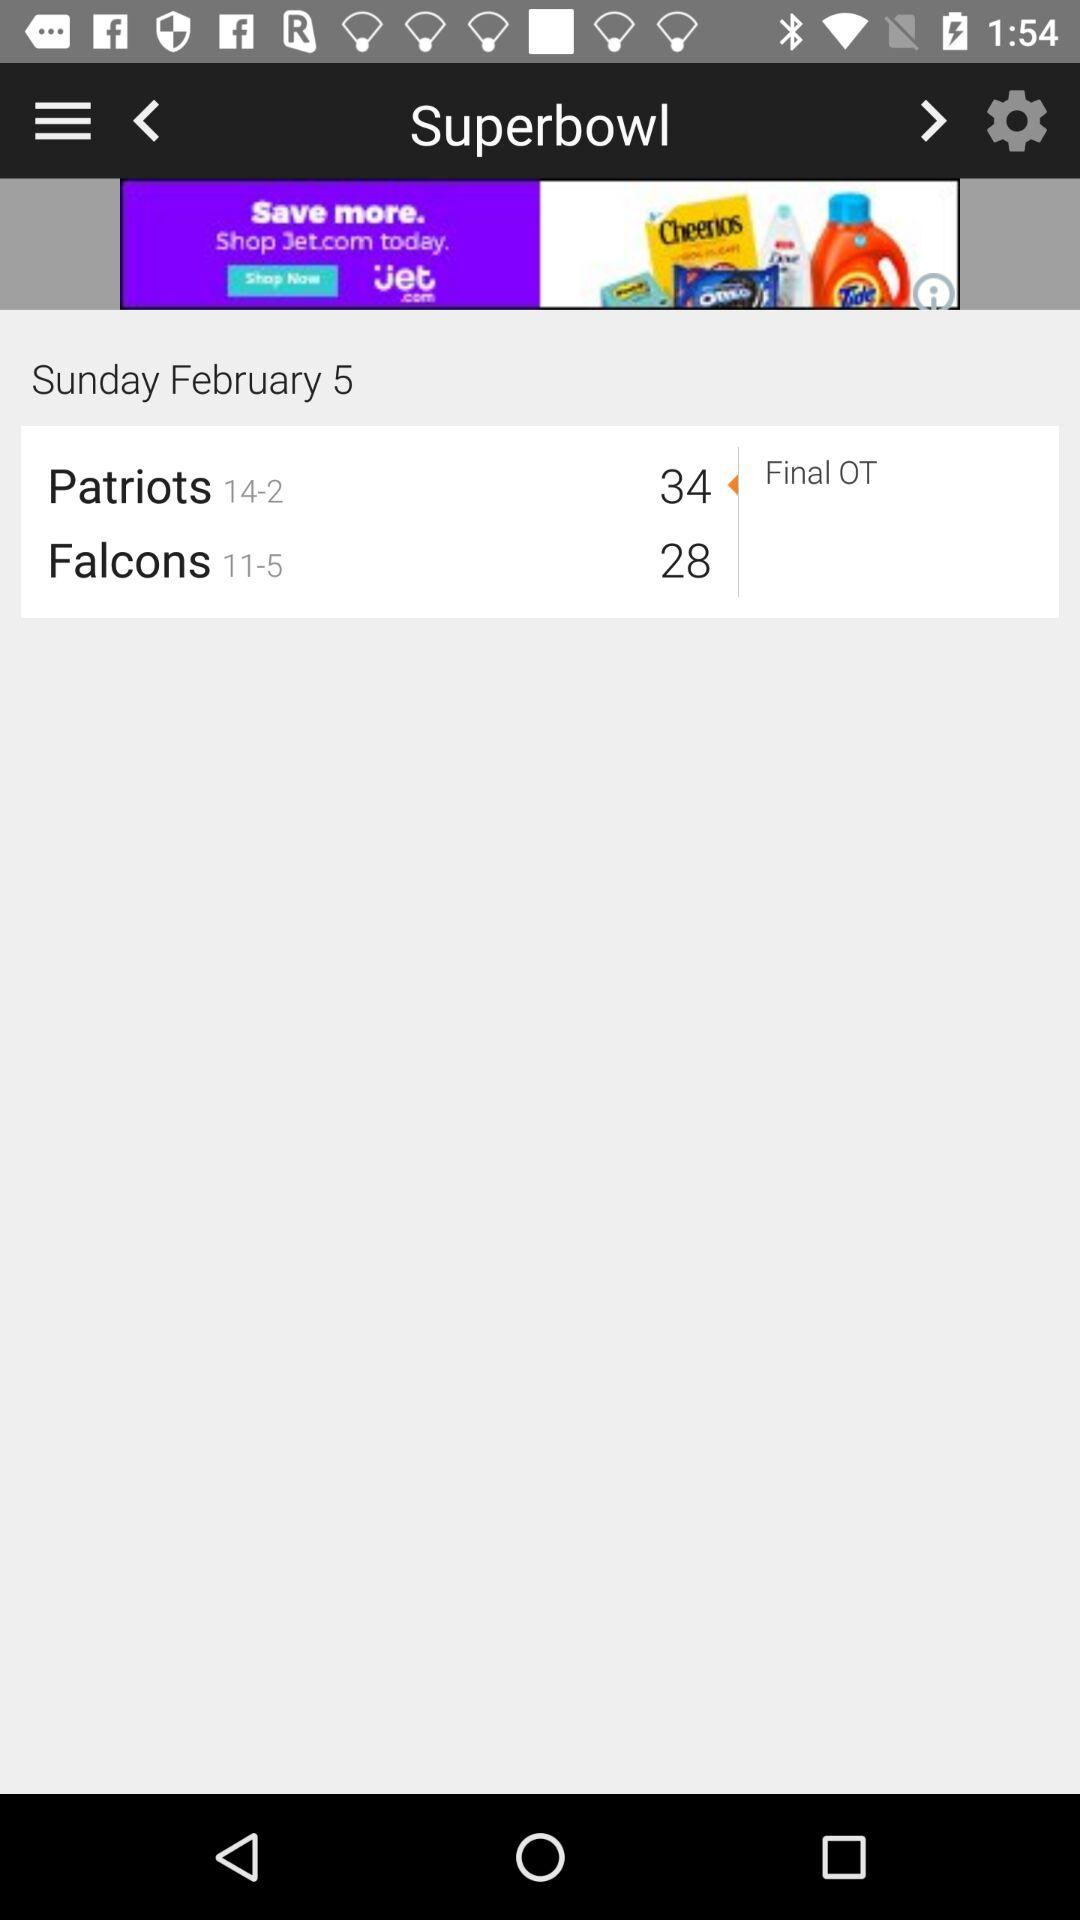What is the score of the "Falcons"? The score of the "Falcons" is 28. 